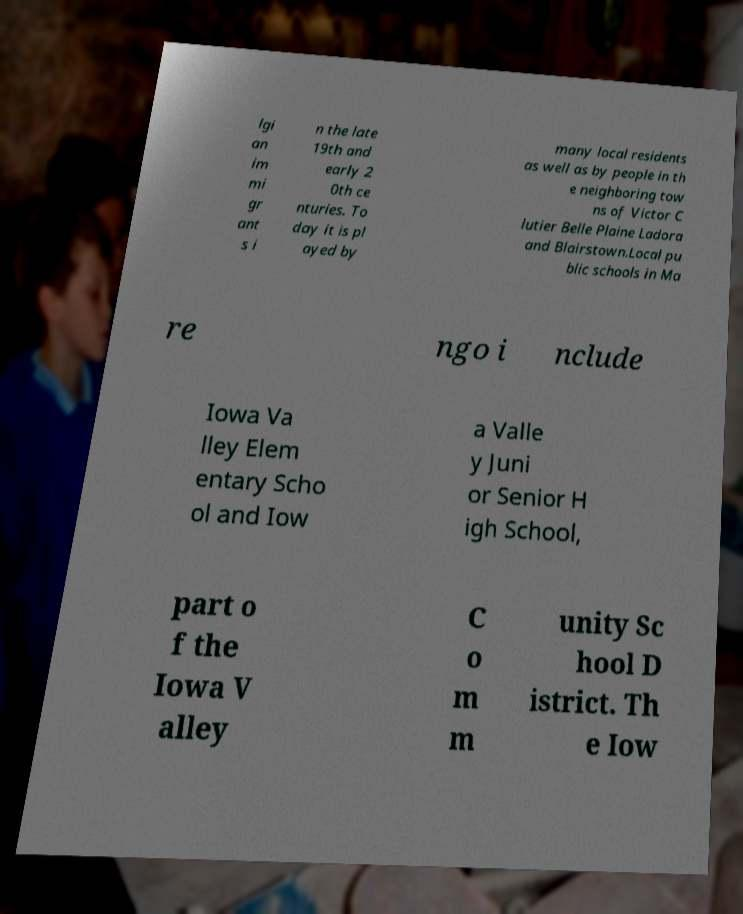There's text embedded in this image that I need extracted. Can you transcribe it verbatim? lgi an im mi gr ant s i n the late 19th and early 2 0th ce nturies. To day it is pl ayed by many local residents as well as by people in th e neighboring tow ns of Victor C lutier Belle Plaine Ladora and Blairstown.Local pu blic schools in Ma re ngo i nclude Iowa Va lley Elem entary Scho ol and Iow a Valle y Juni or Senior H igh School, part o f the Iowa V alley C o m m unity Sc hool D istrict. Th e Iow 